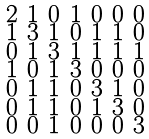Convert formula to latex. <formula><loc_0><loc_0><loc_500><loc_500>\begin{smallmatrix} 2 & 1 & 0 & 1 & 0 & 0 & 0 \\ 1 & 3 & 1 & 0 & 1 & 1 & 0 \\ 0 & 1 & 3 & 1 & 1 & 1 & 1 \\ 1 & 0 & 1 & 3 & 0 & 0 & 0 \\ 0 & 1 & 1 & 0 & 3 & 1 & 0 \\ 0 & 1 & 1 & 0 & 1 & 3 & 0 \\ 0 & 0 & 1 & 0 & 0 & 0 & 3 \end{smallmatrix}</formula> 